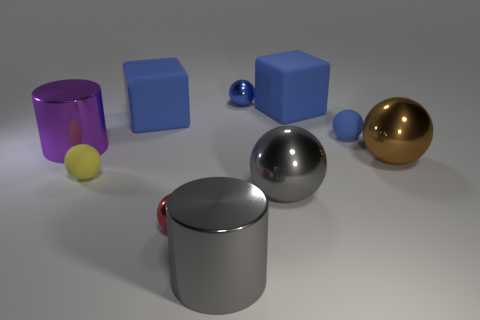There is a tiny blue shiny thing; what shape is it? The tiny blue object in the image is a sphere, exhibiting a smooth and reflective surface which indicates its three-dimensional geometric form. 